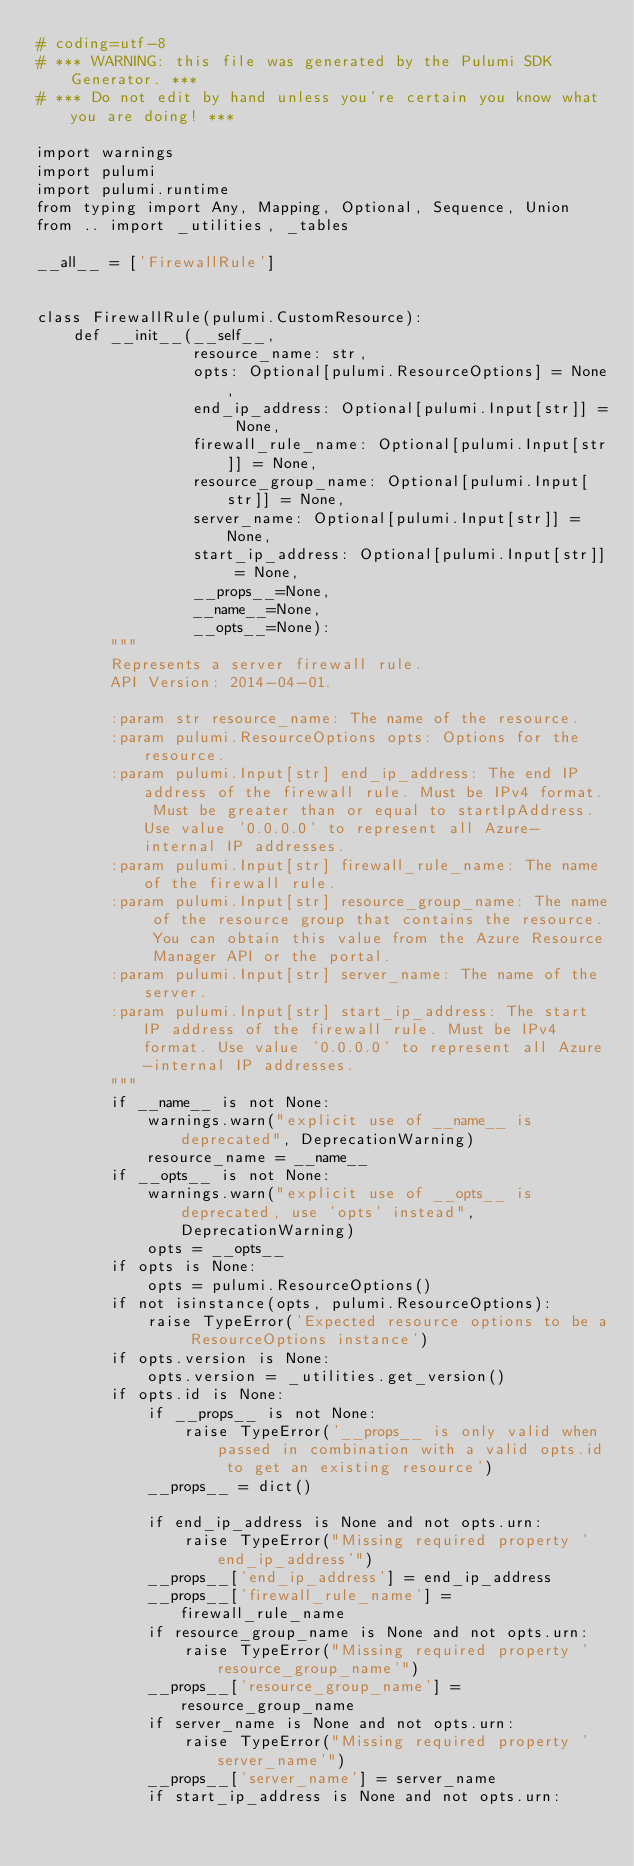Convert code to text. <code><loc_0><loc_0><loc_500><loc_500><_Python_># coding=utf-8
# *** WARNING: this file was generated by the Pulumi SDK Generator. ***
# *** Do not edit by hand unless you're certain you know what you are doing! ***

import warnings
import pulumi
import pulumi.runtime
from typing import Any, Mapping, Optional, Sequence, Union
from .. import _utilities, _tables

__all__ = ['FirewallRule']


class FirewallRule(pulumi.CustomResource):
    def __init__(__self__,
                 resource_name: str,
                 opts: Optional[pulumi.ResourceOptions] = None,
                 end_ip_address: Optional[pulumi.Input[str]] = None,
                 firewall_rule_name: Optional[pulumi.Input[str]] = None,
                 resource_group_name: Optional[pulumi.Input[str]] = None,
                 server_name: Optional[pulumi.Input[str]] = None,
                 start_ip_address: Optional[pulumi.Input[str]] = None,
                 __props__=None,
                 __name__=None,
                 __opts__=None):
        """
        Represents a server firewall rule.
        API Version: 2014-04-01.

        :param str resource_name: The name of the resource.
        :param pulumi.ResourceOptions opts: Options for the resource.
        :param pulumi.Input[str] end_ip_address: The end IP address of the firewall rule. Must be IPv4 format. Must be greater than or equal to startIpAddress. Use value '0.0.0.0' to represent all Azure-internal IP addresses.
        :param pulumi.Input[str] firewall_rule_name: The name of the firewall rule.
        :param pulumi.Input[str] resource_group_name: The name of the resource group that contains the resource. You can obtain this value from the Azure Resource Manager API or the portal.
        :param pulumi.Input[str] server_name: The name of the server.
        :param pulumi.Input[str] start_ip_address: The start IP address of the firewall rule. Must be IPv4 format. Use value '0.0.0.0' to represent all Azure-internal IP addresses.
        """
        if __name__ is not None:
            warnings.warn("explicit use of __name__ is deprecated", DeprecationWarning)
            resource_name = __name__
        if __opts__ is not None:
            warnings.warn("explicit use of __opts__ is deprecated, use 'opts' instead", DeprecationWarning)
            opts = __opts__
        if opts is None:
            opts = pulumi.ResourceOptions()
        if not isinstance(opts, pulumi.ResourceOptions):
            raise TypeError('Expected resource options to be a ResourceOptions instance')
        if opts.version is None:
            opts.version = _utilities.get_version()
        if opts.id is None:
            if __props__ is not None:
                raise TypeError('__props__ is only valid when passed in combination with a valid opts.id to get an existing resource')
            __props__ = dict()

            if end_ip_address is None and not opts.urn:
                raise TypeError("Missing required property 'end_ip_address'")
            __props__['end_ip_address'] = end_ip_address
            __props__['firewall_rule_name'] = firewall_rule_name
            if resource_group_name is None and not opts.urn:
                raise TypeError("Missing required property 'resource_group_name'")
            __props__['resource_group_name'] = resource_group_name
            if server_name is None and not opts.urn:
                raise TypeError("Missing required property 'server_name'")
            __props__['server_name'] = server_name
            if start_ip_address is None and not opts.urn:</code> 